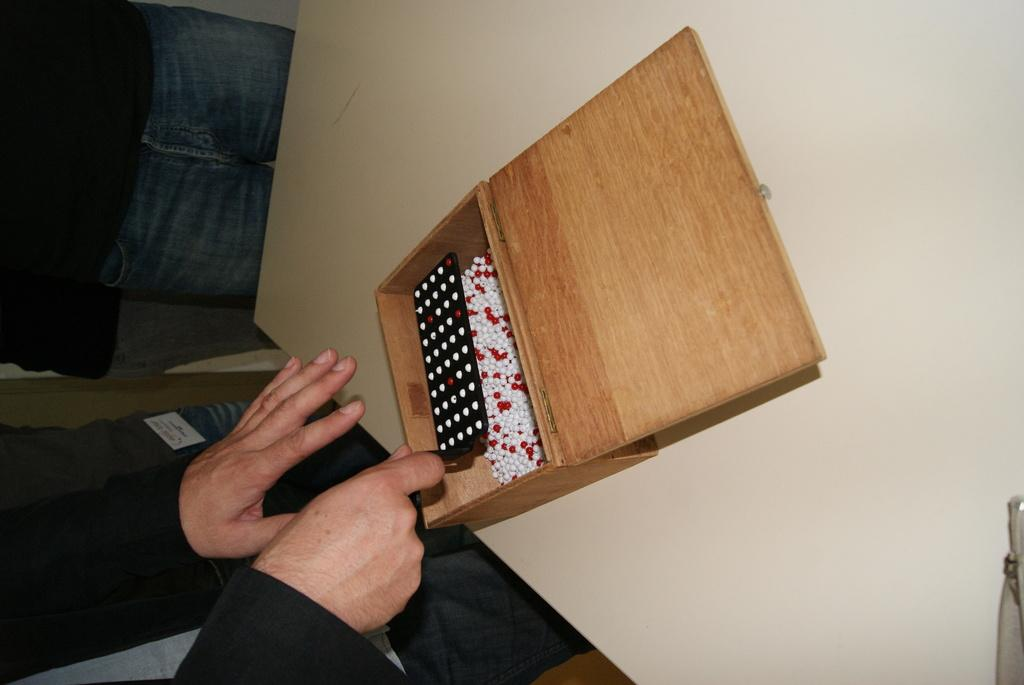What can be seen in the image involving people? There are persons standing in the image. What is the wooden box with balls used for? The wooden box with balls is likely a game or toy. Where is the wooden box located in the image? The wooden box is on a table in the image. What is inside the wooden box? There is an object in the wooden box, which appears to be balls. What type of winter clothing is being worn by the persons in the image? There is no indication of winter clothing or the season in the image; it only shows persons standing and a wooden box with balls. 